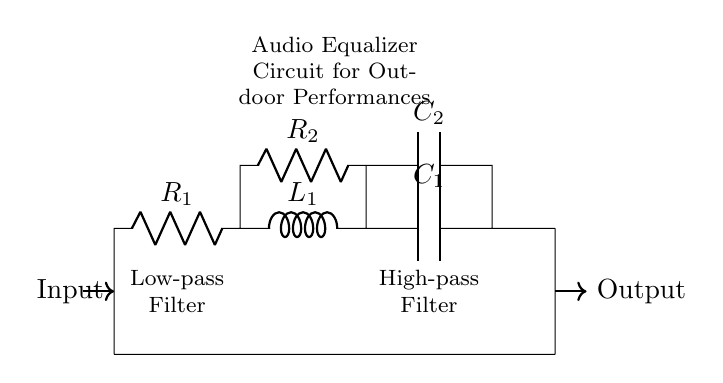What type of circuit is this? The circuit is an audio equalizer circuit designed for optimizing sound quality, specifically incorporating resistors, inductors, and capacitors.
Answer: Audio equalizer circuit How many resistors are present in the circuit? Upon reviewing the circuit, there are two resistors labeled as R1 and R2 connected in the main signal path and feedback configuration.
Answer: Two What is the function of L1 in the circuit? L1 is an inductor, which is typically used for filtering and allows low-frequency signals to pass while attenuating higher frequencies, contributing to the equalization process.
Answer: Filtering Which component is responsible for high-pass filtering? The high-pass filter function is obtained through the configuration with capacitor C2 and resistor R2, that allows high frequencies to pass while blocking lower frequencies.
Answer: Capacitor C2 What is the order of components in the signal pathway? The order in the signal pathway starts from the audio input, going through R1, then L1, followed by C1, and then outputs to the audio out.
Answer: R1, L1, C1 How do resistors affect the audio signal? Resistors R1 and R2 control the amplitude of the audio signal at different frequencies, affecting gain and overall sound quality, allowing desired frequency alignment for performance.
Answer: Gain control 